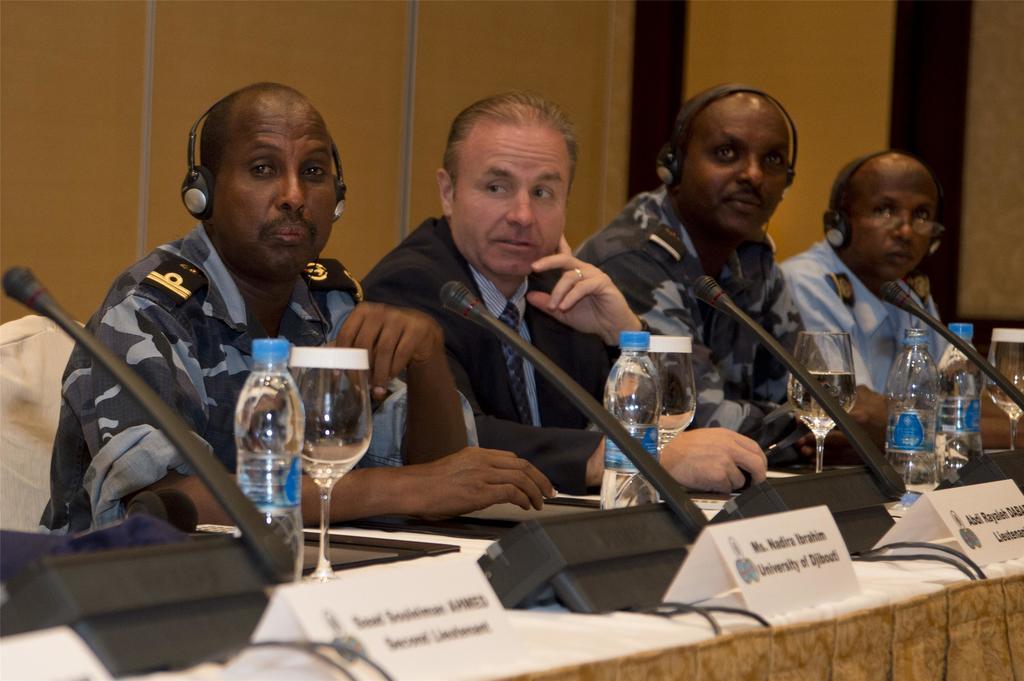Describe this image in one or two sentences. This image is taken inside a room, there are four men in this room. They sat on a chairs. At the bottom of the image there is a table with a name board, mic, water bottle and a glass with water in it, on it. At the background there is a wall. 